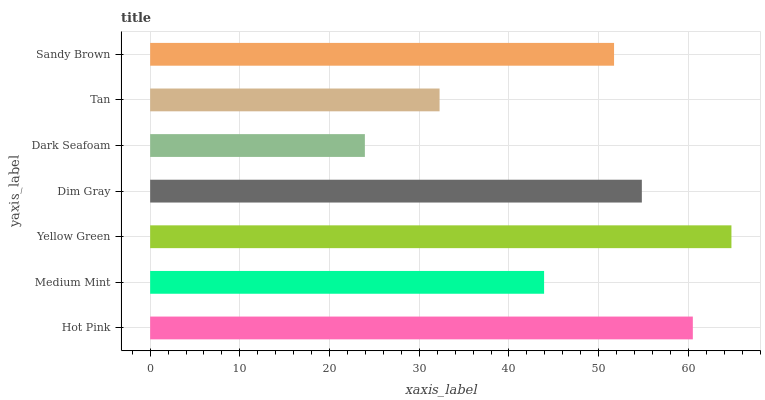Is Dark Seafoam the minimum?
Answer yes or no. Yes. Is Yellow Green the maximum?
Answer yes or no. Yes. Is Medium Mint the minimum?
Answer yes or no. No. Is Medium Mint the maximum?
Answer yes or no. No. Is Hot Pink greater than Medium Mint?
Answer yes or no. Yes. Is Medium Mint less than Hot Pink?
Answer yes or no. Yes. Is Medium Mint greater than Hot Pink?
Answer yes or no. No. Is Hot Pink less than Medium Mint?
Answer yes or no. No. Is Sandy Brown the high median?
Answer yes or no. Yes. Is Sandy Brown the low median?
Answer yes or no. Yes. Is Yellow Green the high median?
Answer yes or no. No. Is Dim Gray the low median?
Answer yes or no. No. 